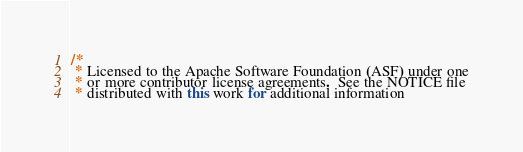Convert code to text. <code><loc_0><loc_0><loc_500><loc_500><_Java_>/*
 * Licensed to the Apache Software Foundation (ASF) under one
 * or more contributor license agreements.  See the NOTICE file
 * distributed with this work for additional information</code> 